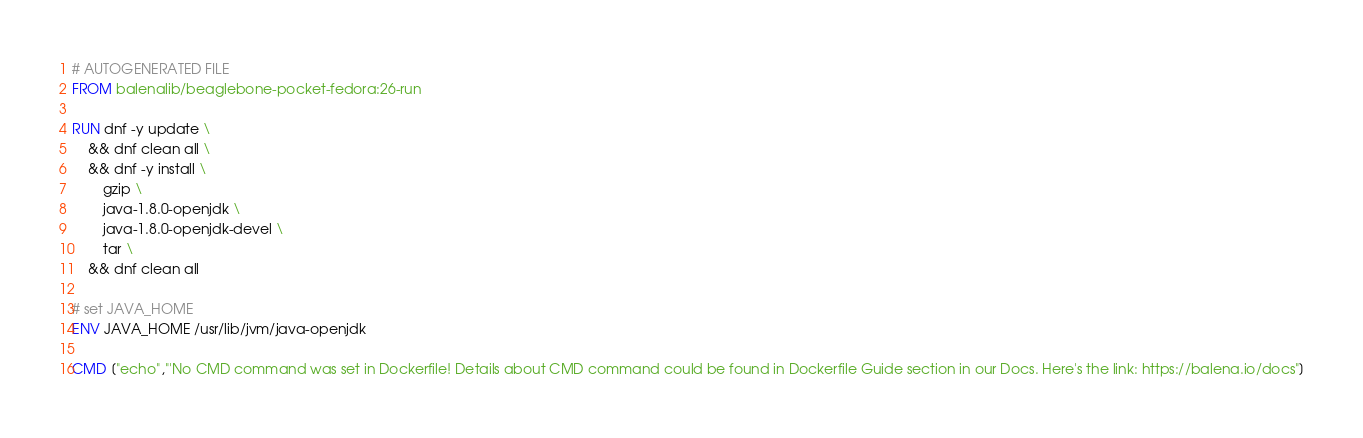Convert code to text. <code><loc_0><loc_0><loc_500><loc_500><_Dockerfile_># AUTOGENERATED FILE
FROM balenalib/beaglebone-pocket-fedora:26-run

RUN dnf -y update \
	&& dnf clean all \
	&& dnf -y install \
		gzip \
		java-1.8.0-openjdk \
		java-1.8.0-openjdk-devel \
		tar \
	&& dnf clean all

# set JAVA_HOME
ENV JAVA_HOME /usr/lib/jvm/java-openjdk

CMD ["echo","'No CMD command was set in Dockerfile! Details about CMD command could be found in Dockerfile Guide section in our Docs. Here's the link: https://balena.io/docs"]</code> 